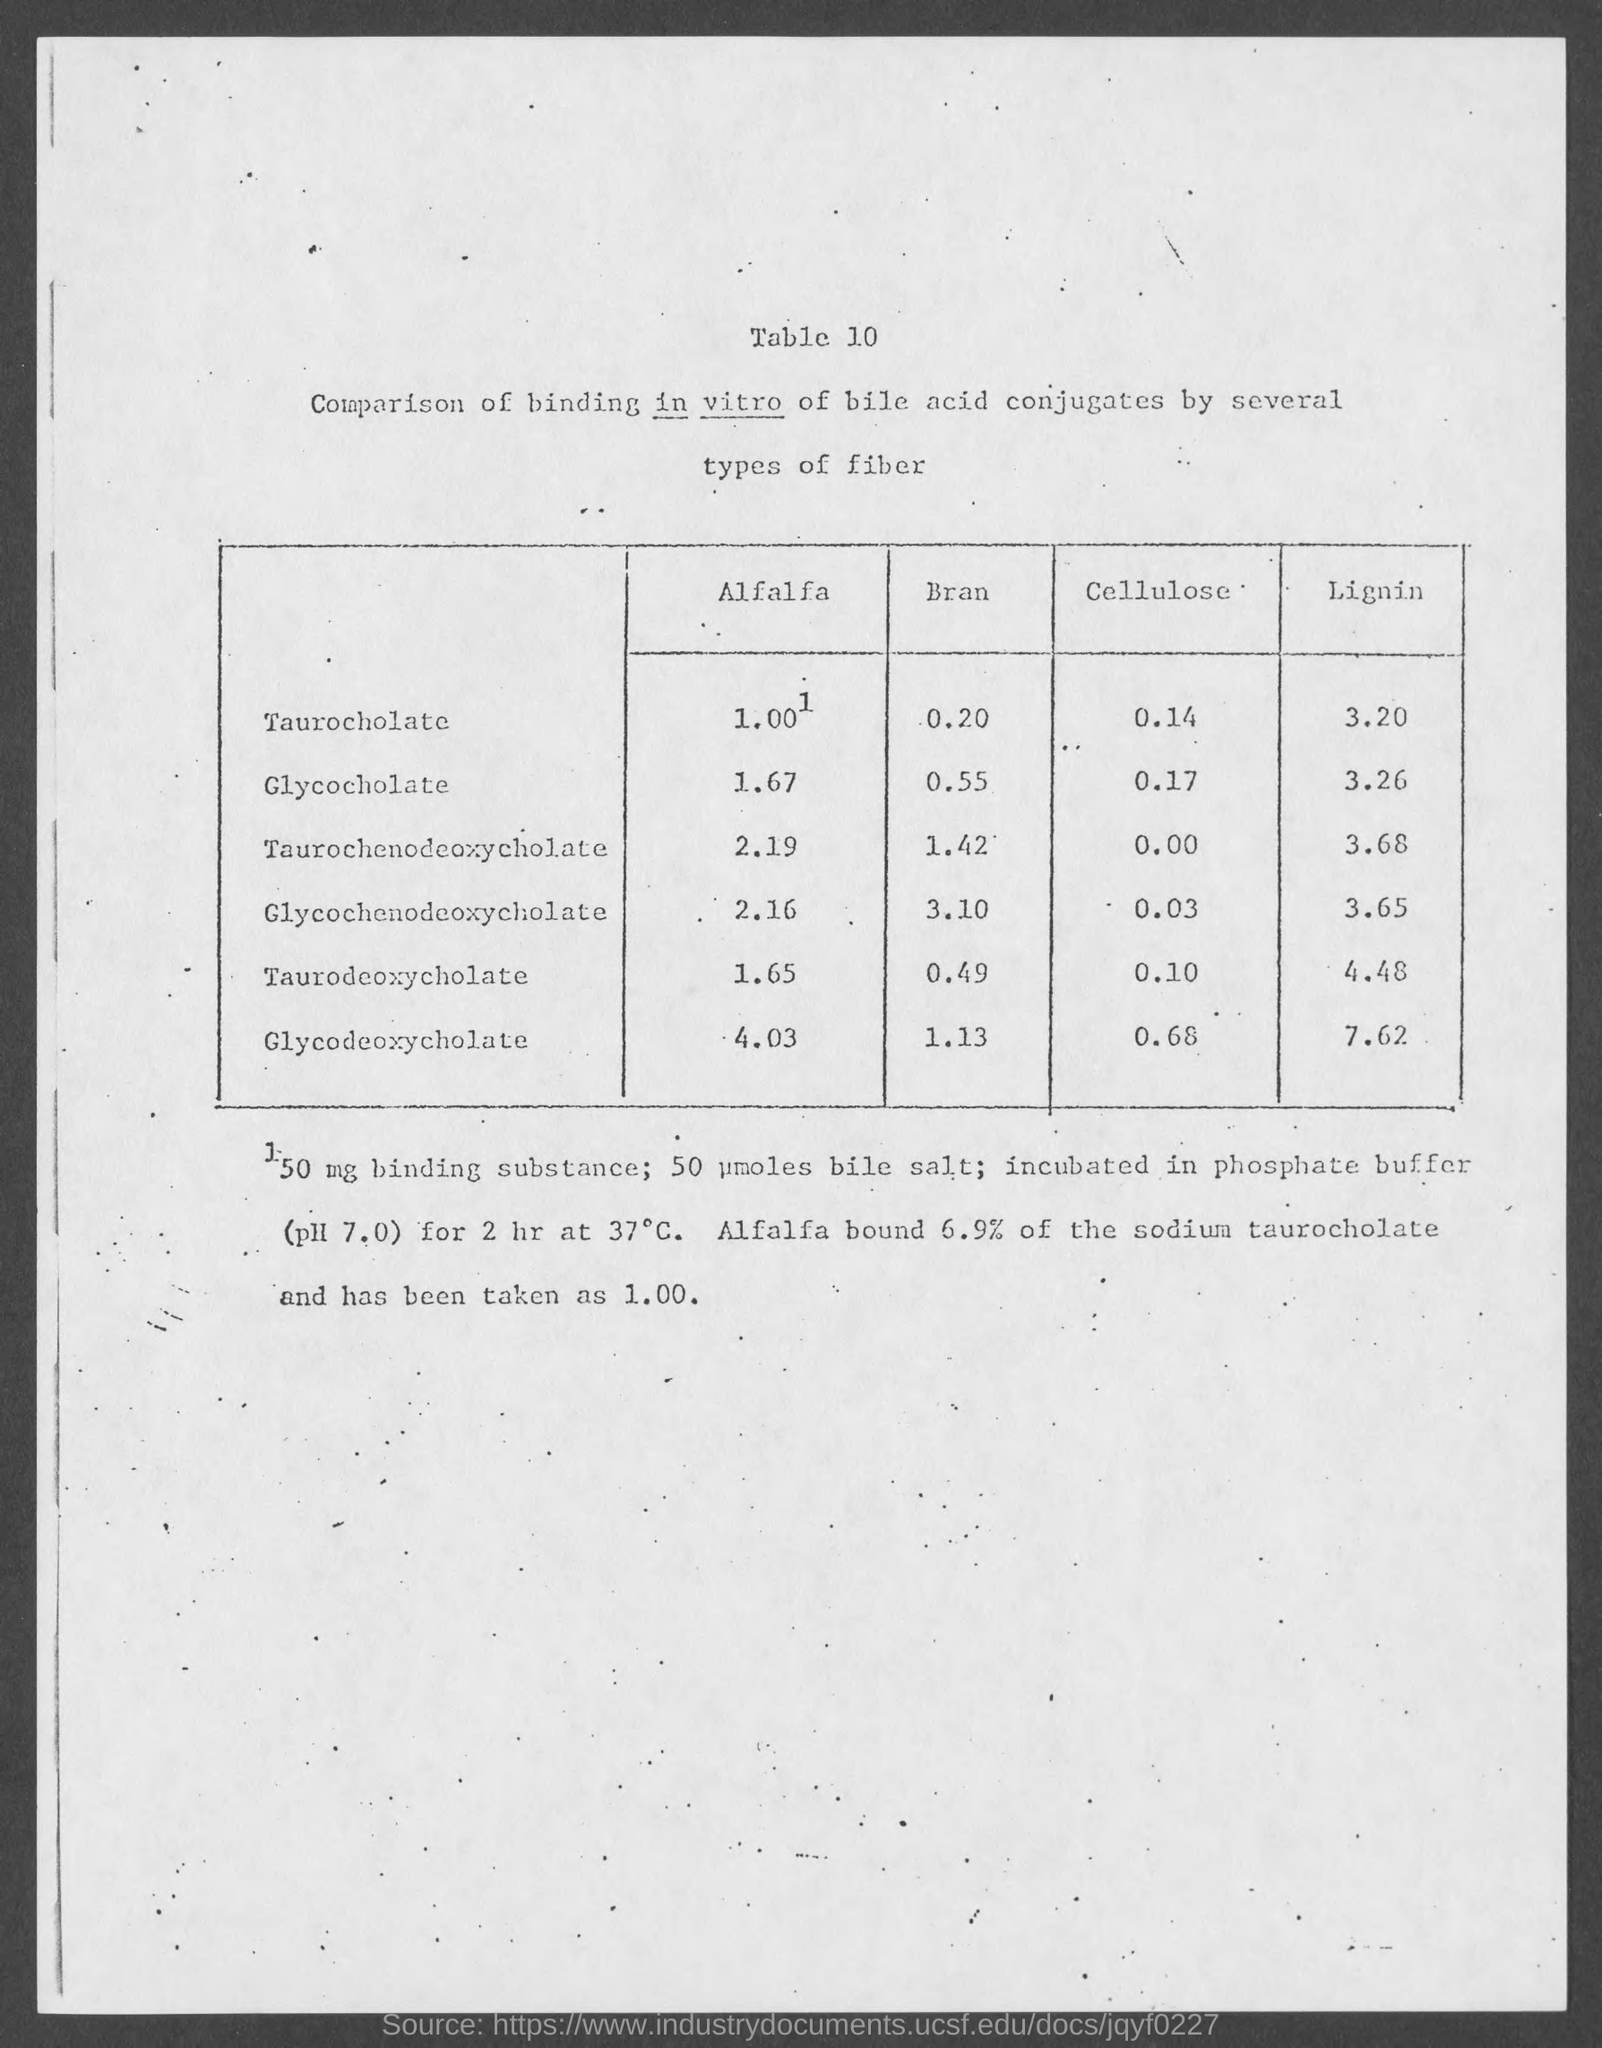What is the title of the table?
Offer a terse response. Comparison of binding in vitro of bile acid conjugates by several types of fiber. What is the value of Glycocholate in Bran?
Offer a terse response. 0.55. What is the value of Taurodeoxycholate in Lignin?
Offer a very short reply. 4.48. 